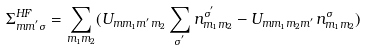<formula> <loc_0><loc_0><loc_500><loc_500>\Sigma _ { m m ^ { ^ { \prime } } \sigma } ^ { H F } = \sum _ { m _ { 1 } m _ { 2 } } ( U _ { m m _ { 1 } m ^ { ^ { \prime } } m _ { 2 } } \sum _ { \sigma ^ { ^ { \prime } } } n _ { m _ { 1 } m _ { 2 } } ^ { \sigma ^ { ^ { \prime } } } - U _ { m m _ { 1 } m _ { 2 } m ^ { ^ { \prime } } } n _ { m _ { 1 } m _ { 2 } } ^ { \sigma } )</formula> 